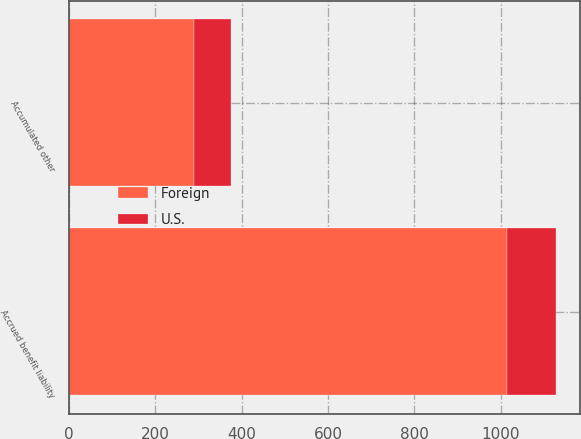Convert chart. <chart><loc_0><loc_0><loc_500><loc_500><stacked_bar_chart><ecel><fcel>Accrued benefit liability<fcel>Accumulated other<nl><fcel>U.S.<fcel>114<fcel>86<nl><fcel>Foreign<fcel>1014<fcel>289<nl></chart> 